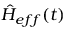<formula> <loc_0><loc_0><loc_500><loc_500>\hat { H } _ { e f f } ( t )</formula> 